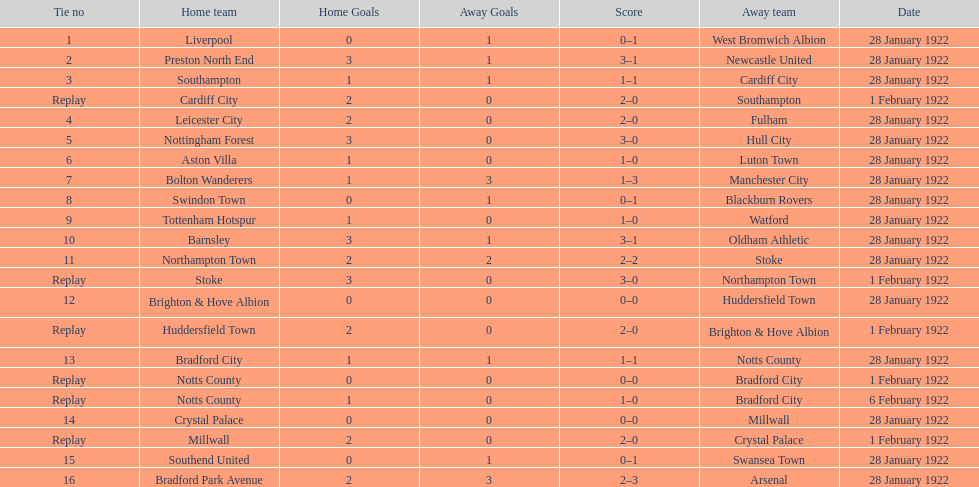Who is the first home team listed as having a score of 3-1? Preston North End. 